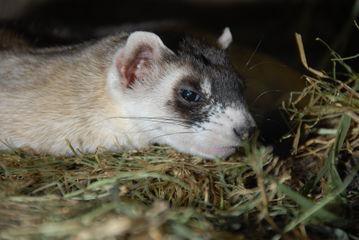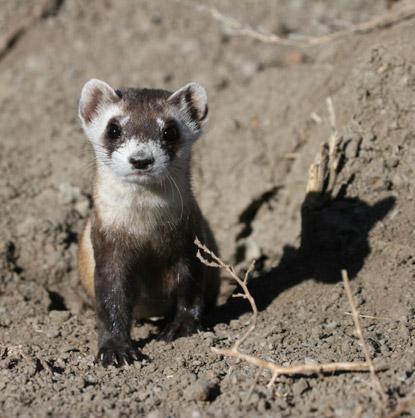The first image is the image on the left, the second image is the image on the right. Evaluate the accuracy of this statement regarding the images: "The animal in the image on the right is in side profile turned toward the left with its face turned toward the camera.". Is it true? Answer yes or no. No. 